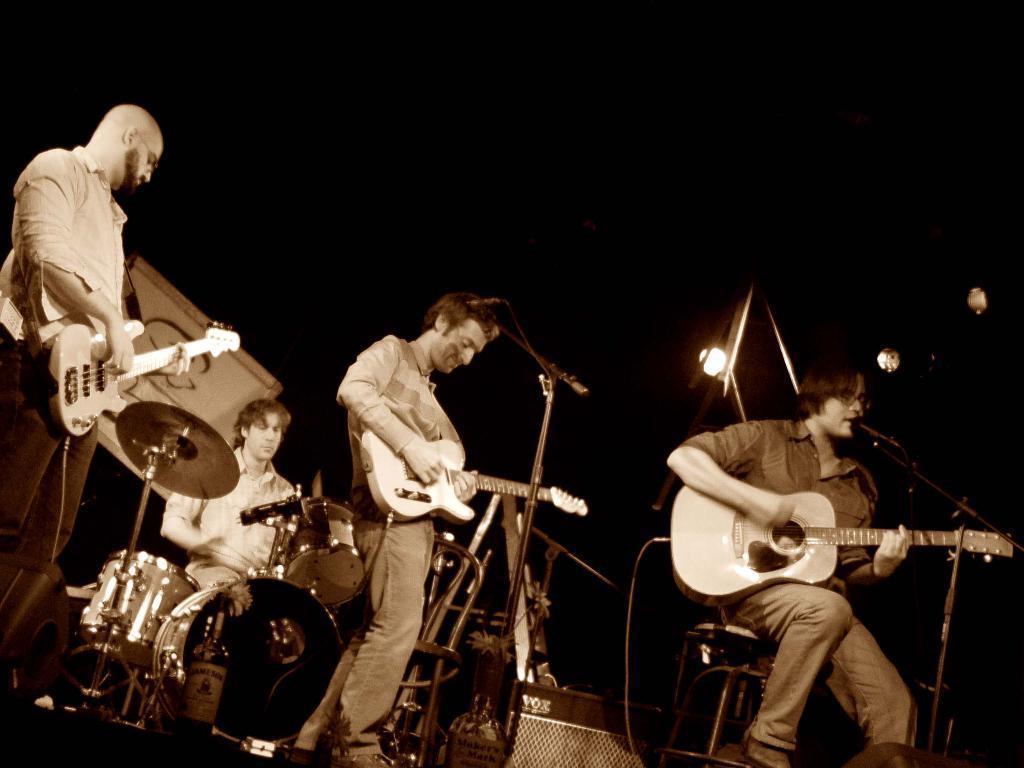Could you give a brief overview of what you see in this image? This picture show three men playing guitars and we see a man seated and singing with the help of a microphone and we see two men standing and we see a man seated and playing drums on the back and we see a dark background 